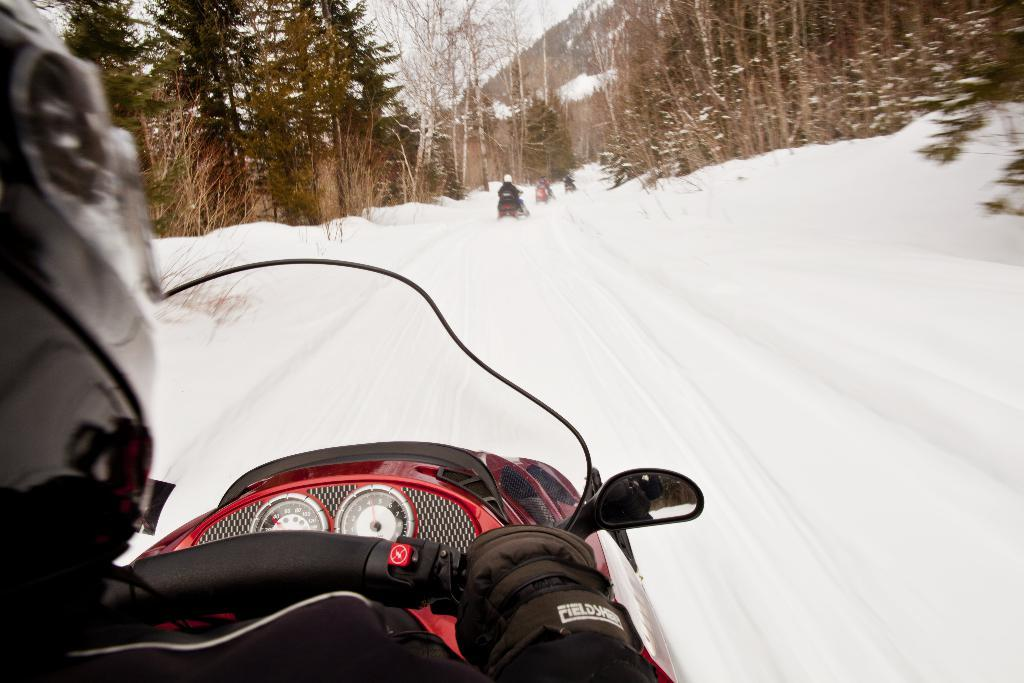What type of vehicles are in the image? There are snow bikes in the image. What can be seen in the background of the image? There are trees in the image. What protective gear are the people wearing while riding the snow bikes? The people riding the snow bikes are wearing helmets. What type of hobbies can be seen being practiced on the land in the image? There is no specific mention of land or hobbies in the image; it features snow bikes and trees. 